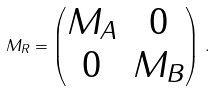Convert formula to latex. <formula><loc_0><loc_0><loc_500><loc_500>M _ { R } = \begin{pmatrix} M _ { A } & 0 \\ 0 & M _ { B } \end{pmatrix} \, .</formula> 